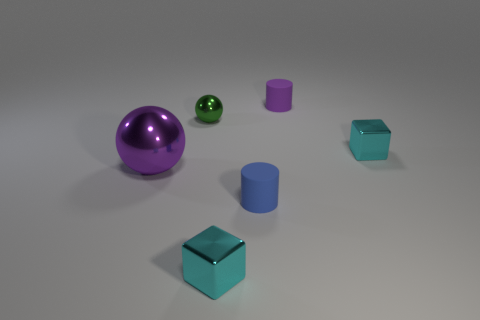What color is the large thing? purple 